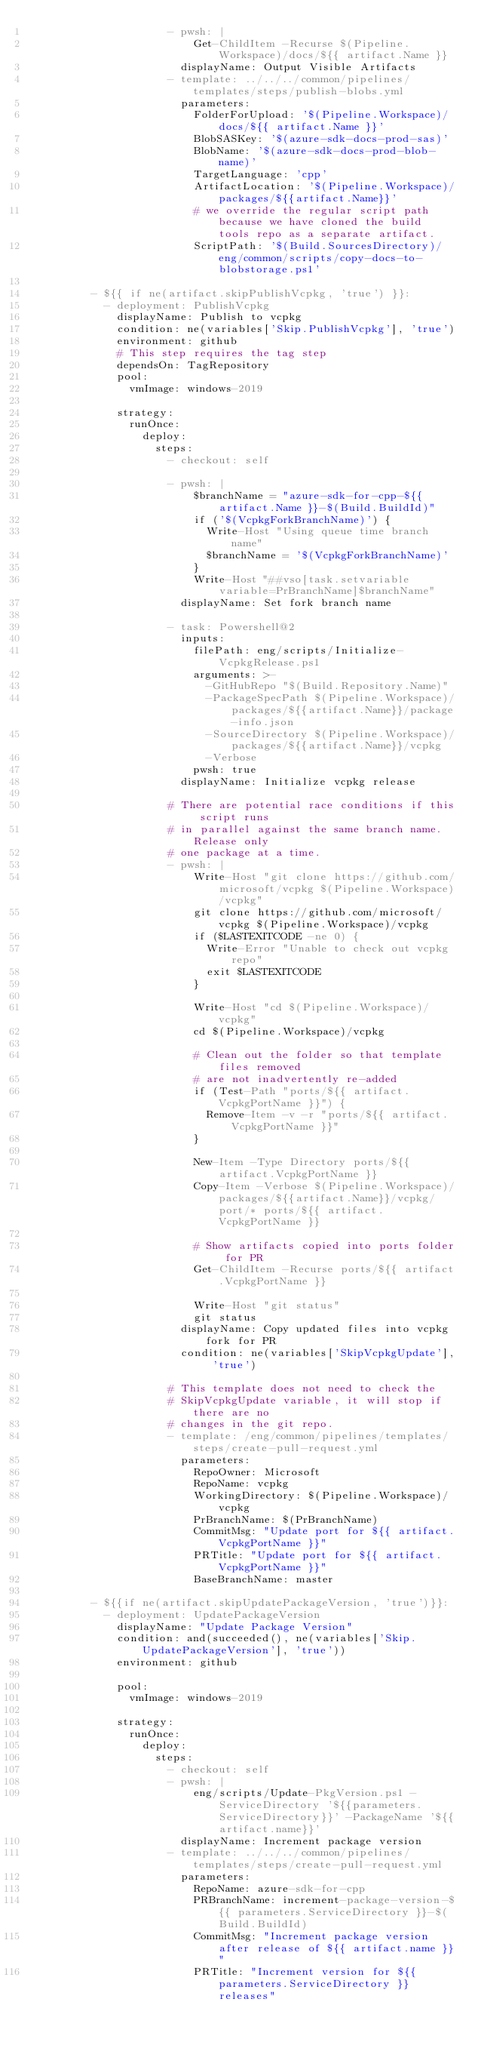<code> <loc_0><loc_0><loc_500><loc_500><_YAML_>                      - pwsh: |
                          Get-ChildItem -Recurse $(Pipeline.Workspace)/docs/${{ artifact.Name }}
                        displayName: Output Visible Artifacts
                      - template: ../../../common/pipelines/templates/steps/publish-blobs.yml
                        parameters:
                          FolderForUpload: '$(Pipeline.Workspace)/docs/${{ artifact.Name }}'
                          BlobSASKey: '$(azure-sdk-docs-prod-sas)'
                          BlobName: '$(azure-sdk-docs-prod-blob-name)'
                          TargetLanguage: 'cpp'
                          ArtifactLocation: '$(Pipeline.Workspace)/packages/${{artifact.Name}}'
                          # we override the regular script path because we have cloned the build tools repo as a separate artifact.
                          ScriptPath: '$(Build.SourcesDirectory)/eng/common/scripts/copy-docs-to-blobstorage.ps1'

          - ${{ if ne(artifact.skipPublishVcpkg, 'true') }}:
            - deployment: PublishVcpkg
              displayName: Publish to vcpkg
              condition: ne(variables['Skip.PublishVcpkg'], 'true')
              environment: github
              # This step requires the tag step
              dependsOn: TagRepository
              pool:
                vmImage: windows-2019

              strategy:
                runOnce:
                  deploy:
                    steps:
                      - checkout: self

                      - pwsh: |
                          $branchName = "azure-sdk-for-cpp-${{ artifact.Name }}-$(Build.BuildId)"
                          if ('$(VcpkgForkBranchName)') { 
                            Write-Host "Using queue time branch name" 
                            $branchName = '$(VcpkgForkBranchName)'
                          } 
                          Write-Host "##vso[task.setvariable variable=PrBranchName]$branchName"
                        displayName: Set fork branch name

                      - task: Powershell@2
                        inputs:
                          filePath: eng/scripts/Initialize-VcpkgRelease.ps1
                          arguments: >-
                            -GitHubRepo "$(Build.Repository.Name)"
                            -PackageSpecPath $(Pipeline.Workspace)/packages/${{artifact.Name}}/package-info.json
                            -SourceDirectory $(Pipeline.Workspace)/packages/${{artifact.Name}}/vcpkg
                            -Verbose
                          pwsh: true
                        displayName: Initialize vcpkg release

                      # There are potential race conditions if this script runs
                      # in parallel against the same branch name. Release only 
                      # one package at a time.
                      - pwsh: |
                          Write-Host "git clone https://github.com/microsoft/vcpkg $(Pipeline.Workspace)/vcpkg"
                          git clone https://github.com/microsoft/vcpkg $(Pipeline.Workspace)/vcpkg
                          if ($LASTEXITCODE -ne 0) {
                            Write-Error "Unable to check out vcpkg repo"
                            exit $LASTEXITCODE
                          }
                          
                          Write-Host "cd $(Pipeline.Workspace)/vcpkg"
                          cd $(Pipeline.Workspace)/vcpkg

                          # Clean out the folder so that template files removed
                          # are not inadvertently re-added
                          if (Test-Path "ports/${{ artifact.VcpkgPortName }}") {
                            Remove-Item -v -r "ports/${{ artifact.VcpkgPortName }}"
                          }

                          New-Item -Type Directory ports/${{ artifact.VcpkgPortName }}
                          Copy-Item -Verbose $(Pipeline.Workspace)/packages/${{artifact.Name}}/vcpkg/port/* ports/${{ artifact.VcpkgPortName }}

                          # Show artifacts copied into ports folder for PR
                          Get-ChildItem -Recurse ports/${{ artifact.VcpkgPortName }}
                          
                          Write-Host "git status"
                          git status
                        displayName: Copy updated files into vcpkg fork for PR
                        condition: ne(variables['SkipVcpkgUpdate'], 'true')

                      # This template does not need to check the 
                      # SkipVcpkgUpdate variable, it will stop if there are no
                      # changes in the git repo.
                      - template: /eng/common/pipelines/templates/steps/create-pull-request.yml
                        parameters:
                          RepoOwner: Microsoft
                          RepoName: vcpkg
                          WorkingDirectory: $(Pipeline.Workspace)/vcpkg
                          PrBranchName: $(PrBranchName)
                          CommitMsg: "Update port for ${{ artifact.VcpkgPortName }}"
                          PRTitle: "Update port for ${{ artifact.VcpkgPortName }}"
                          BaseBranchName: master

          - ${{if ne(artifact.skipUpdatePackageVersion, 'true')}}:
            - deployment: UpdatePackageVersion
              displayName: "Update Package Version"
              condition: and(succeeded(), ne(variables['Skip.UpdatePackageVersion'], 'true'))
              environment: github

              pool:
                vmImage: windows-2019

              strategy:
                runOnce:
                  deploy:
                    steps:
                      - checkout: self
                      - pwsh: |
                          eng/scripts/Update-PkgVersion.ps1 -ServiceDirectory '${{parameters.ServiceDirectory}}' -PackageName '${{artifact.name}}'
                        displayName: Increment package version
                      - template: ../../../common/pipelines/templates/steps/create-pull-request.yml
                        parameters:
                          RepoName: azure-sdk-for-cpp
                          PRBranchName: increment-package-version-${{ parameters.ServiceDirectory }}-$(Build.BuildId)
                          CommitMsg: "Increment package version after release of ${{ artifact.name }}"
                          PRTitle: "Increment version for ${{ parameters.ServiceDirectory }} releases"</code> 